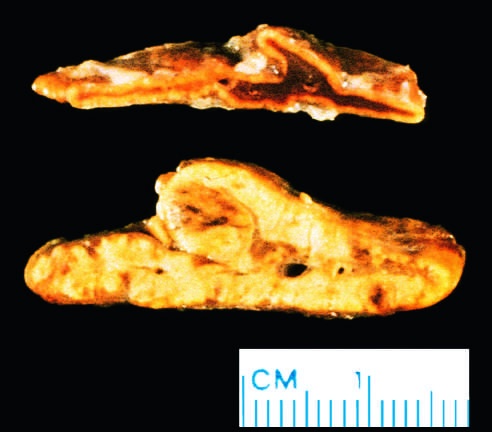s the b-cell antigen receptor complex evident?
Answer the question using a single word or phrase. No 